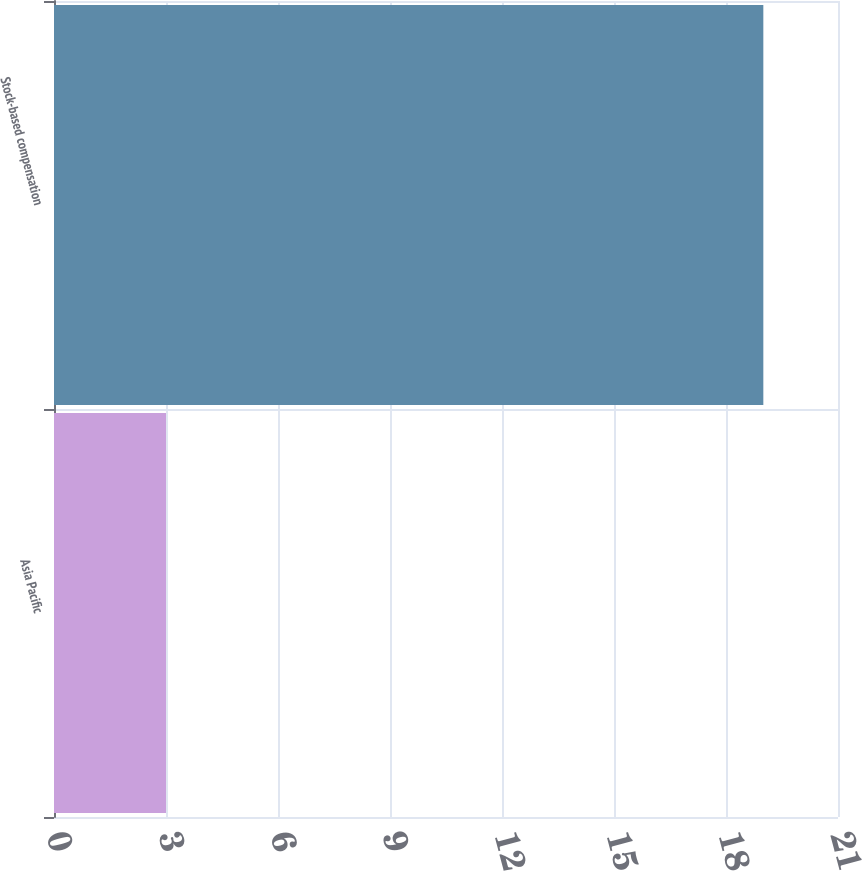Convert chart to OTSL. <chart><loc_0><loc_0><loc_500><loc_500><bar_chart><fcel>Asia Pacific<fcel>Stock-based compensation<nl><fcel>3<fcel>19<nl></chart> 